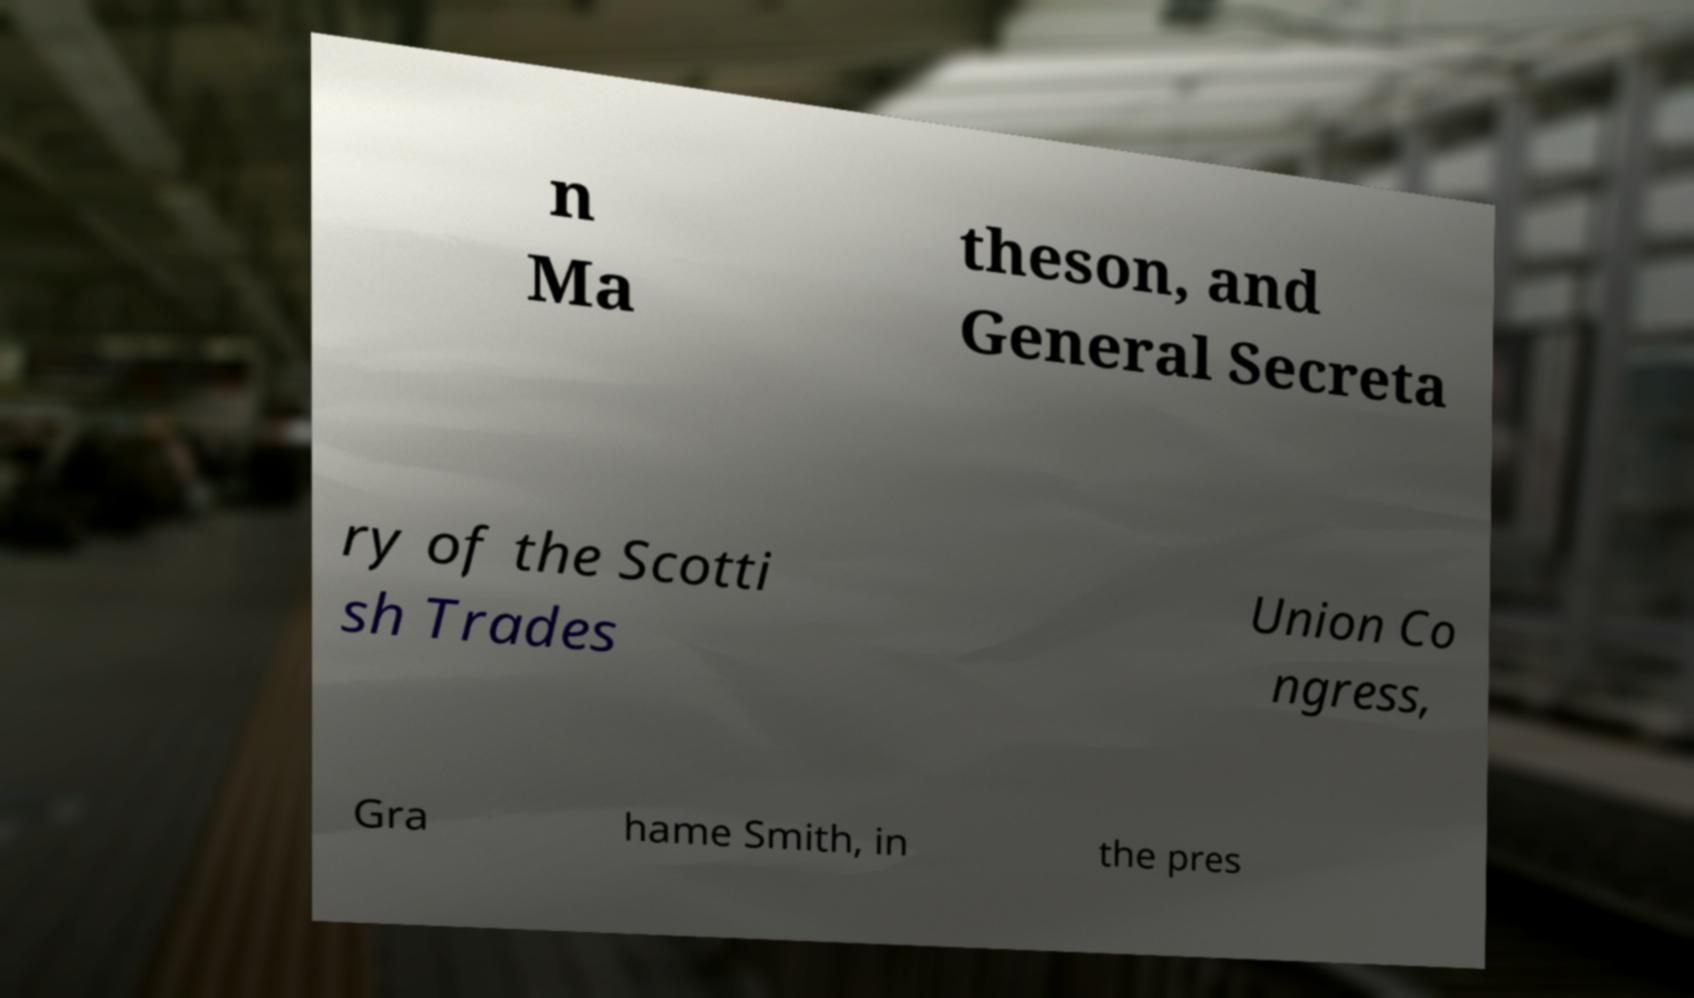Please identify and transcribe the text found in this image. n Ma theson, and General Secreta ry of the Scotti sh Trades Union Co ngress, Gra hame Smith, in the pres 